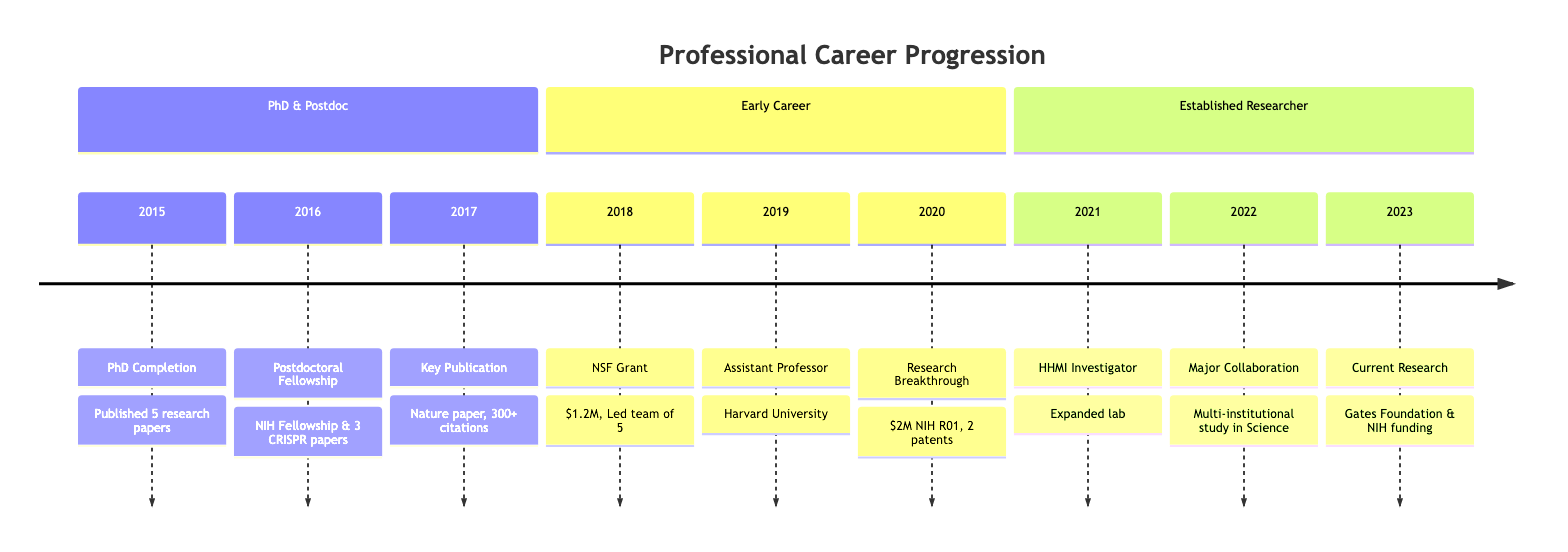What year did you complete your PhD? The diagram indicates that the PhD was completed in 2015, as that event is explicitly mentioned with the corresponding year in the timeline.
Answer: 2015 How many research papers were published during the postdoctoral fellowship? According to the timeline, during the postdoctoral fellowship in 2016, 3 research papers were published on CRISPR technology, which is directly stated in the accomplishments of that event.
Answer: 3 What significant award was received in 2018? The timeline states that a $1.2 million grant was awarded from the National Science Foundation in 2018, making it a significant recognition of funding that year.
Answer: $1.2 million grant How many PhD students were mentored in 2019? The timeline notes that in 2019, 3 PhD students were mentored, as listed under the accomplishments for that year, indicating direct engagement in academic mentorship.
Answer: 3 What was the focus of research in 2023? The timeline indicates that in 2023, the focus was on applications of CRISPR for rare genetic disorders, showing the specific area of research spotlighted that year.
Answer: CRISPR for rare genetic disorders Which prestigious fellowship was awarded in 2021? According to the timeline, the Howard Hughes Medical Institute Investigator Fellowship was awarded in 2021, as explicitly stated under that year's event.
Answer: Howard Hughes Medical Institute Investigator Fellowship What was the cumulative citation count of the key publication in 2017? The diagram specifies that the groundbreaking paper published in 2017 was cited over 300 times, which directly answers the question about its citation count.
Answer: 300+ Which institution did you join as an Assistant Professor? The timeline mentions that the position of Assistant Professor was secured at Harvard University in 2019, providing a clear answer about the specific institution.
Answer: Harvard University How much funding was secured from the NIH in 2020? The timeline explicitly states that a $2 million NIH R01 grant was secured in 2020, making it a straightforward piece of information regarding funding that year.
Answer: $2 million NIH R01 grant 